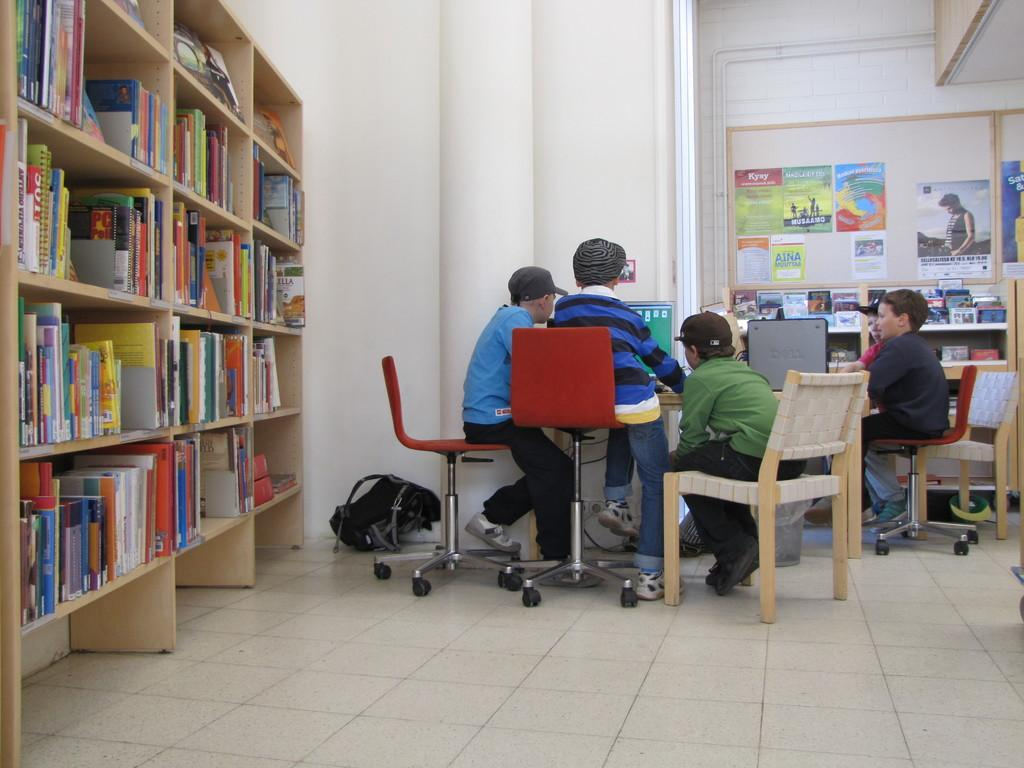What are the people in the image doing? The people in the image are sitting on chairs and looking at a computer. What can be seen on the left side of the image? There is a bookshelf on the left side of the image. What is stored on the bookshelf? The bookshelf contains many books. What is present on the wall in the image? There are posters on the wall in the image. Is there any smoke coming from the computer in the image? No, there is no smoke present in the image. 